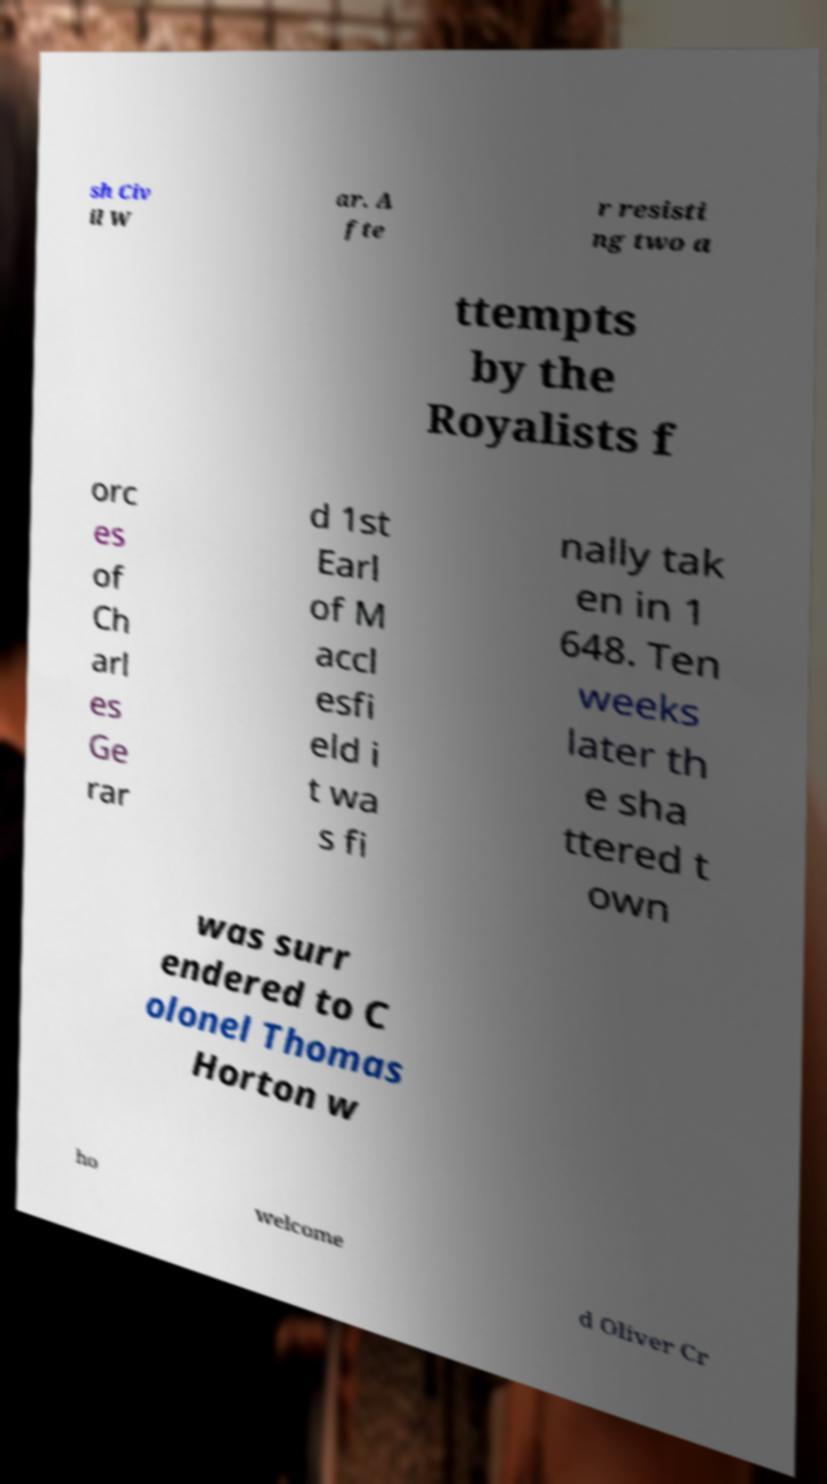Can you accurately transcribe the text from the provided image for me? sh Civ il W ar. A fte r resisti ng two a ttempts by the Royalists f orc es of Ch arl es Ge rar d 1st Earl of M accl esfi eld i t wa s fi nally tak en in 1 648. Ten weeks later th e sha ttered t own was surr endered to C olonel Thomas Horton w ho welcome d Oliver Cr 